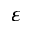Convert formula to latex. <formula><loc_0><loc_0><loc_500><loc_500>\varepsilon</formula> 